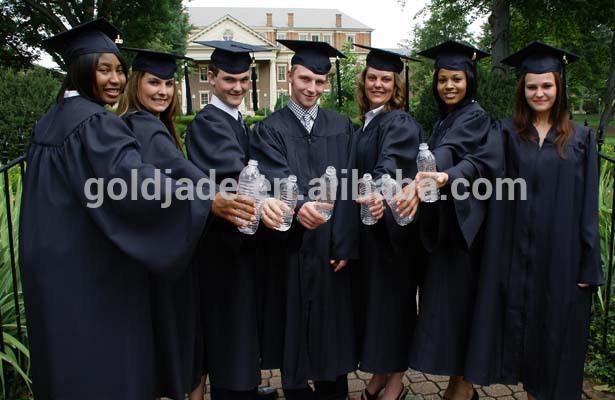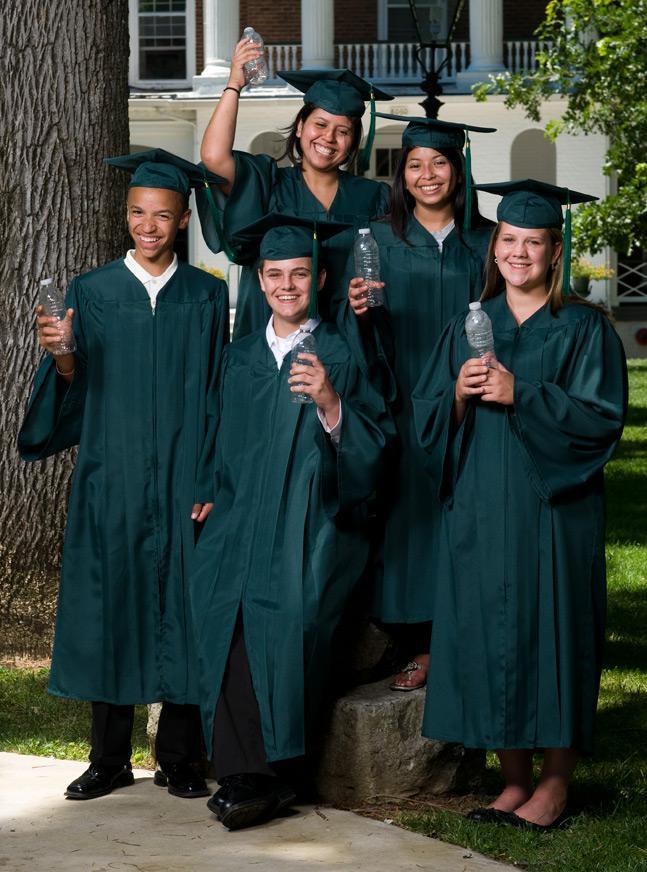The first image is the image on the left, the second image is the image on the right. Given the left and right images, does the statement "At least three camera-facing graduates in burgundy robes are in one image." hold true? Answer yes or no. No. The first image is the image on the left, the second image is the image on the right. For the images displayed, is the sentence "All graduates in each image are wearing identical gowns and sashes." factually correct? Answer yes or no. Yes. The first image is the image on the left, the second image is the image on the right. Examine the images to the left and right. Is the description "In one image, at least three graduates are wearing red gowns and caps, while a second image shows at least four graduates in black gowns with gold sashes." accurate? Answer yes or no. No. The first image is the image on the left, the second image is the image on the right. Evaluate the accuracy of this statement regarding the images: "An image includes multiple graduates in wine-colored gowns.". Is it true? Answer yes or no. No. 